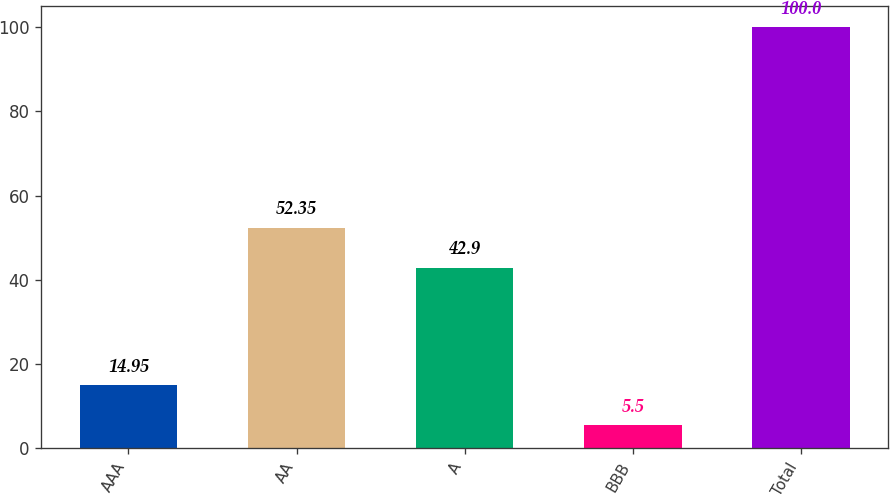Convert chart. <chart><loc_0><loc_0><loc_500><loc_500><bar_chart><fcel>AAA<fcel>AA<fcel>A<fcel>BBB<fcel>Total<nl><fcel>14.95<fcel>52.35<fcel>42.9<fcel>5.5<fcel>100<nl></chart> 